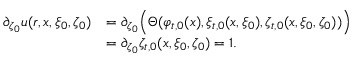Convert formula to latex. <formula><loc_0><loc_0><loc_500><loc_500>\begin{array} { r l } { \partial _ { \zeta _ { 0 } } u ( r , x , \xi _ { 0 } , \zeta _ { 0 } ) } & { = \partial _ { \zeta _ { 0 } } \left ( \Theta ( \varphi _ { t , 0 } ( x ) , \xi _ { t , 0 } ( x , \xi _ { 0 } ) , \zeta _ { t , 0 } ( x , \xi _ { 0 } , \zeta _ { 0 } ) ) \right ) } \\ & { = \partial _ { \zeta _ { 0 } } \zeta _ { t , 0 } ( x , \xi _ { 0 } , \zeta _ { 0 } ) = 1 . } \end{array}</formula> 